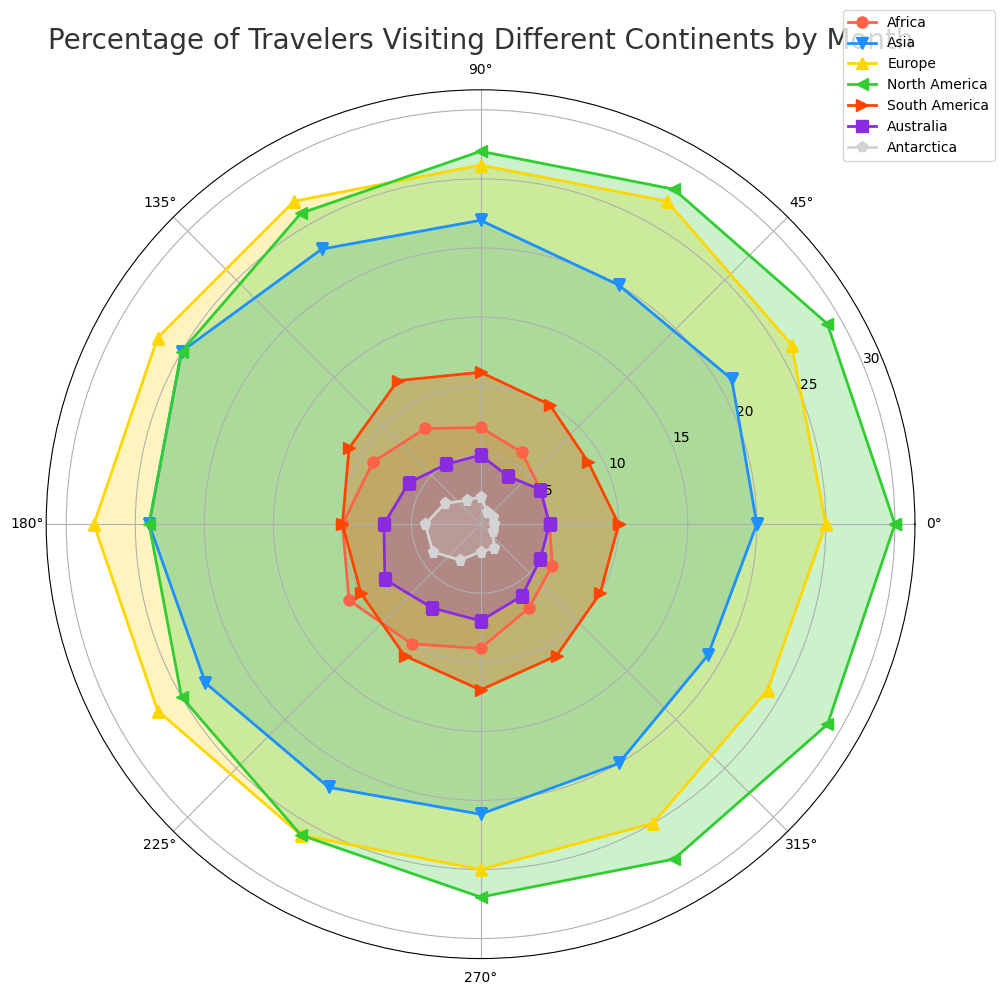Which continent sees the highest percentage of travelers in July? In the rose chart, July corresponds to the position on the chart marked by the seventh marker from the beginning. From the plotted lines, North America reaches the highest percentage in July.
Answer: North America During which months do Africa and Australia have equal percentages of travelers? To find this, examine both Africa (red line) and Australia (purple line) on the chart. Look for intersections of these two lines across months. You can see that they both have 5% in January and February.
Answer: January and February Which continent shows the largest percentage change between January and December? Compare the starting and ending points for each continent. North America starts at 30% in January and rises to 29% in December, which is less of a change compared to Antarctica, which starts at 1% in January and goes up to 1% as well. The largest percentage change is seen in Europe, starting at 25% in January and dropping to 24% in December.
Answer: Europe Does Asia have more travelers in June or November, and by how much? Visually compare the percentage of travelers for Asia (blue line) in June and November. June is represented by the sixth marker, and November is the eleventh. In June, Asia is at 25%, and in November, it is at 20%. The difference is 25% - 20%.
Answer: June, 5% Which month has the highest combined percentage of travelers across all continents? To answer this, add up the percentages for each month. For simplicity, visually estimate or use calculations from the data table. The highest combined percentages are typically observed in July and August, but detailed addition shows July (Africa:10, Asia:24, Europe:28, North America:24, South America:10, Australia:7, Antarctica:4) sums up to the highest total.
Answer: July How does the percentage of travelers to South America change from May to August? Track the points for South America (orange line) across May, June, July, and August. From the chart: May (12%), June (11%), July (10%), and August (10%). The percent changes from 12% in May to 10% in August.
Answer: It decreases by 2% In which month does Europe have its highest percentage of travelers? Refer to the yellow line that represents Europe in the chart and find the peak point. The highest percentage observed is in July, where it reaches 28%.
Answer: July What color represents Antarctica, and what does its percentage trend look like? Identify the light gray line for Antarctica on the chart. Its trend starts low at 1% in January, peaks at 4% by July, and then decreases back to 1% by December.
Answer: Light gray, increases and then decreases By what percentage does the number of travelers to North America change from March to September? Evaluate the percentages of travelers to North America (green line) in March (28%) and September (26%). The change is the difference, (28% - 26%).
Answer: Decreases by 2% Which continent has the lowest percentage of travelers in February, and what is that percentage? Check the percentages for all the continents in February. Antarctica consistently has the lowest percentage, which is 1%.
Answer: Antarctica, 1% 